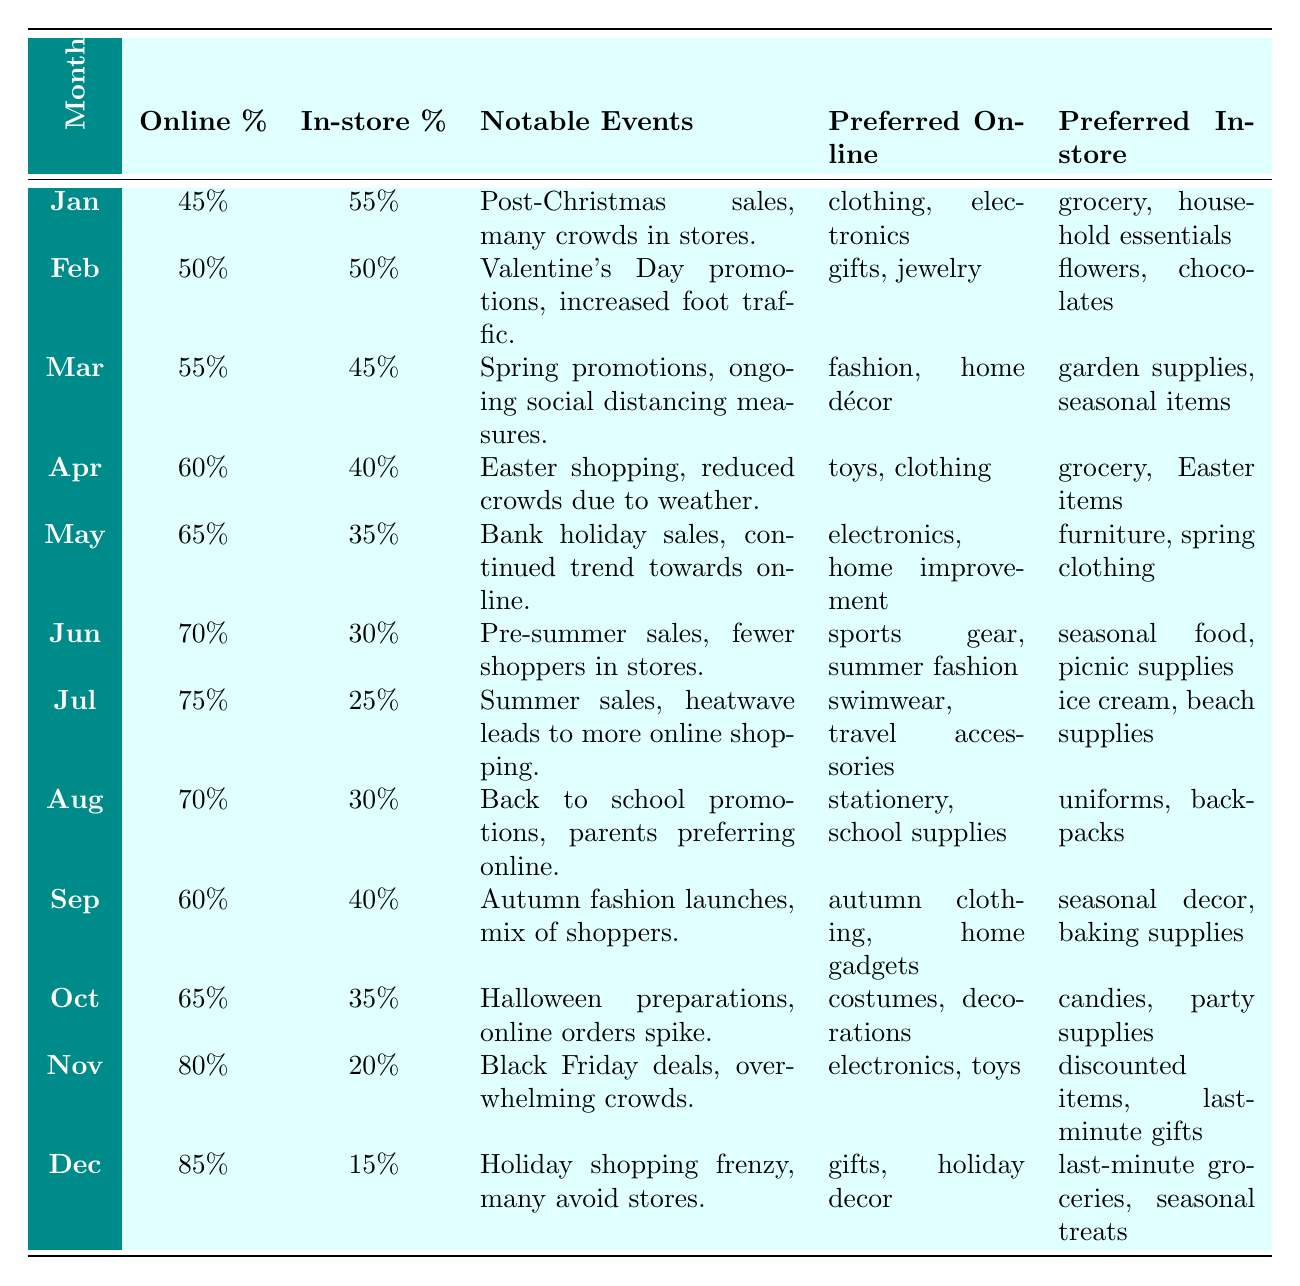What was the online shopping percentage in November? In November, the online shopping percentage is stated in the table as 80%.
Answer: 80% What notable event in December contributed to the avoidance of in-store shopping? The table notes that in December there was a "Holiday shopping frenzy, many avoid stores," which implies that the high number of online transactions was due to this event.
Answer: Holiday shopping frenzy Which month saw the highest online shopping percentage? By looking through the table, December has the highest online shopping percentage at 85%.
Answer: 85% Was there an increase in online shopping percentages from February to March? Checking the table, the online shopping percentage in February was 50%, and in March it increased to 55%, confirming that there was an increase.
Answer: Yes What were the preferred online categories during the summer sales in July? Referring to the table, in July the preferred online categories are "swimwear" and "travel accessories."
Answer: Swimwear and travel accessories About how much more did people prefer online shopping in November compared to in-store shopping? November shows an online shopping percentage of 80% and an in-store shopping percentage of 20%. The difference is 80 - 20 = 60.
Answer: 60% During which month was there an equal preference for online and in-store shopping? In February, the table indicates that both online and in-store shopping percentages were both 50%.
Answer: February What was the favored in-store shopping category in September? The table lists "seasonal decor" and "baking supplies" as the preferred in-store shopping categories for September.
Answer: Seasonal decor and baking supplies Did online shopping outpace in-store shopping at any point during the year? From the data, it can be seen that online shopping surpassed in-store shopping starting in March, consistently increasing each month thereafter.
Answer: Yes 